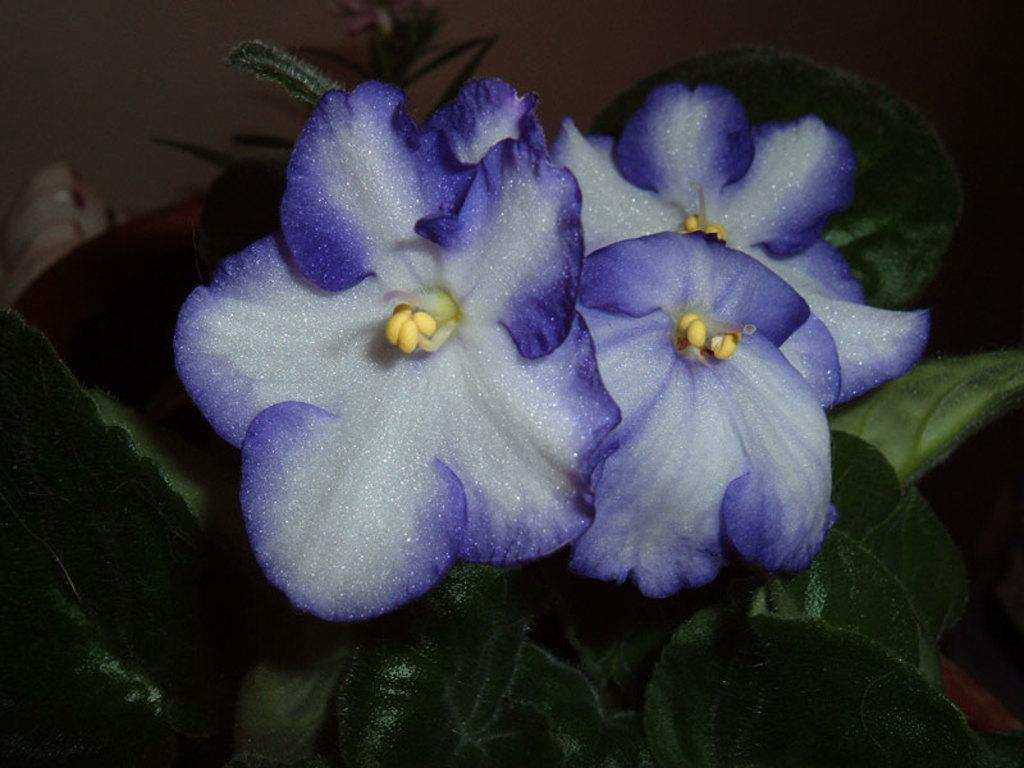What is present in the image? There is a plant in the image. What can be observed about the flowers on the plant? The flowers on the plant have a bluish white color. What flavor of ice cream does the plant prefer in the image? The plant does not have a preference for ice cream flavor, as it is a plant and not capable of having such preferences. 